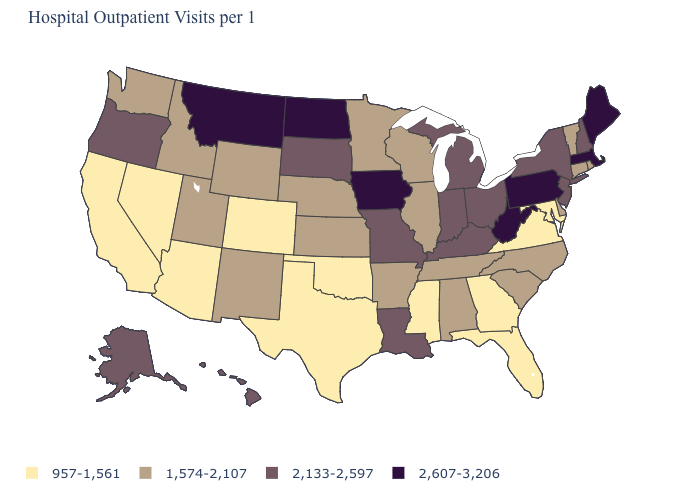Does Missouri have a lower value than Kansas?
Keep it brief. No. What is the value of Maryland?
Be succinct. 957-1,561. How many symbols are there in the legend?
Write a very short answer. 4. How many symbols are there in the legend?
Quick response, please. 4. What is the highest value in the USA?
Answer briefly. 2,607-3,206. Name the states that have a value in the range 2,607-3,206?
Give a very brief answer. Iowa, Maine, Massachusetts, Montana, North Dakota, Pennsylvania, West Virginia. Name the states that have a value in the range 2,607-3,206?
Short answer required. Iowa, Maine, Massachusetts, Montana, North Dakota, Pennsylvania, West Virginia. Name the states that have a value in the range 1,574-2,107?
Be succinct. Alabama, Arkansas, Connecticut, Delaware, Idaho, Illinois, Kansas, Minnesota, Nebraska, New Mexico, North Carolina, Rhode Island, South Carolina, Tennessee, Utah, Vermont, Washington, Wisconsin, Wyoming. What is the value of Oklahoma?
Keep it brief. 957-1,561. Which states hav the highest value in the West?
Write a very short answer. Montana. What is the value of Pennsylvania?
Answer briefly. 2,607-3,206. Is the legend a continuous bar?
Answer briefly. No. Is the legend a continuous bar?
Write a very short answer. No. Name the states that have a value in the range 2,133-2,597?
Short answer required. Alaska, Hawaii, Indiana, Kentucky, Louisiana, Michigan, Missouri, New Hampshire, New Jersey, New York, Ohio, Oregon, South Dakota. Name the states that have a value in the range 2,607-3,206?
Give a very brief answer. Iowa, Maine, Massachusetts, Montana, North Dakota, Pennsylvania, West Virginia. 